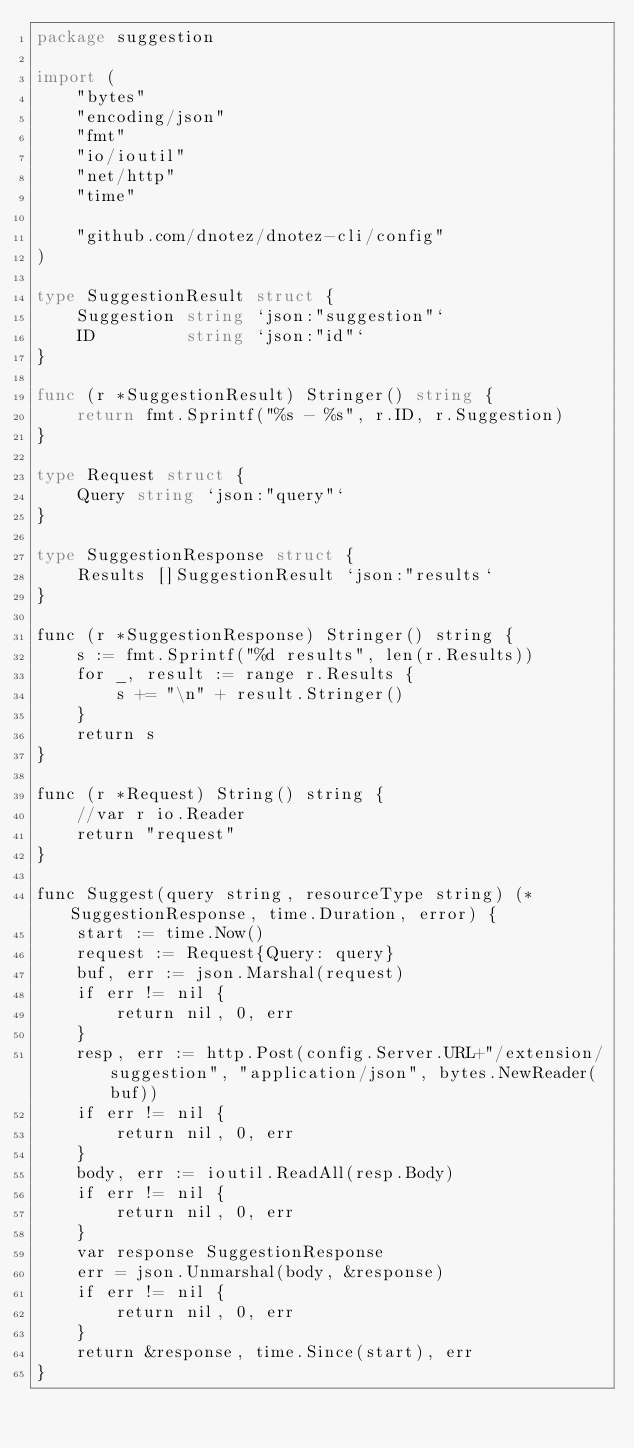<code> <loc_0><loc_0><loc_500><loc_500><_Go_>package suggestion

import (
	"bytes"
	"encoding/json"
	"fmt"
	"io/ioutil"
	"net/http"
	"time"

	"github.com/dnotez/dnotez-cli/config"
)

type SuggestionResult struct {
	Suggestion string `json:"suggestion"`
	ID         string `json:"id"`
}

func (r *SuggestionResult) Stringer() string {
	return fmt.Sprintf("%s - %s", r.ID, r.Suggestion)
}

type Request struct {
	Query string `json:"query"`
}

type SuggestionResponse struct {
	Results []SuggestionResult `json:"results`
}

func (r *SuggestionResponse) Stringer() string {
	s := fmt.Sprintf("%d results", len(r.Results))
	for _, result := range r.Results {
		s += "\n" + result.Stringer()
	}
	return s
}

func (r *Request) String() string {
	//var r io.Reader
	return "request"
}

func Suggest(query string, resourceType string) (*SuggestionResponse, time.Duration, error) {
	start := time.Now()
	request := Request{Query: query}
	buf, err := json.Marshal(request)
	if err != nil {
		return nil, 0, err
	}
	resp, err := http.Post(config.Server.URL+"/extension/suggestion", "application/json", bytes.NewReader(buf))
	if err != nil {
		return nil, 0, err
	}
	body, err := ioutil.ReadAll(resp.Body)
	if err != nil {
		return nil, 0, err
	}
	var response SuggestionResponse
	err = json.Unmarshal(body, &response)
	if err != nil {
		return nil, 0, err
	}
	return &response, time.Since(start), err
}
</code> 